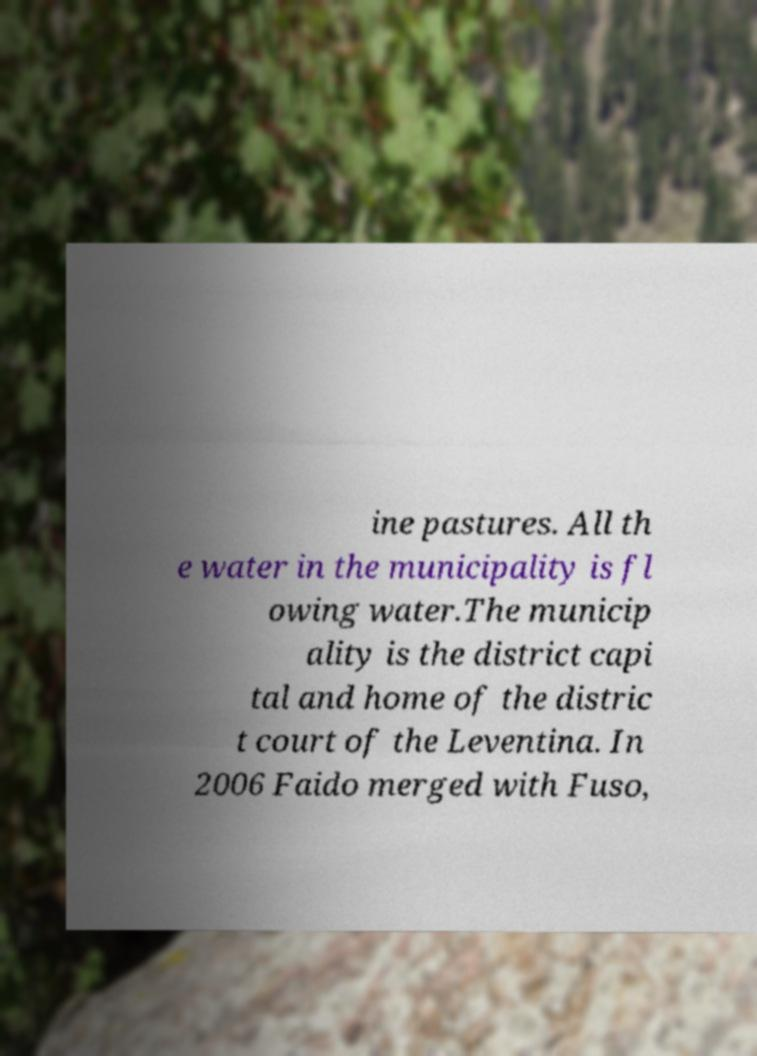Could you assist in decoding the text presented in this image and type it out clearly? ine pastures. All th e water in the municipality is fl owing water.The municip ality is the district capi tal and home of the distric t court of the Leventina. In 2006 Faido merged with Fuso, 